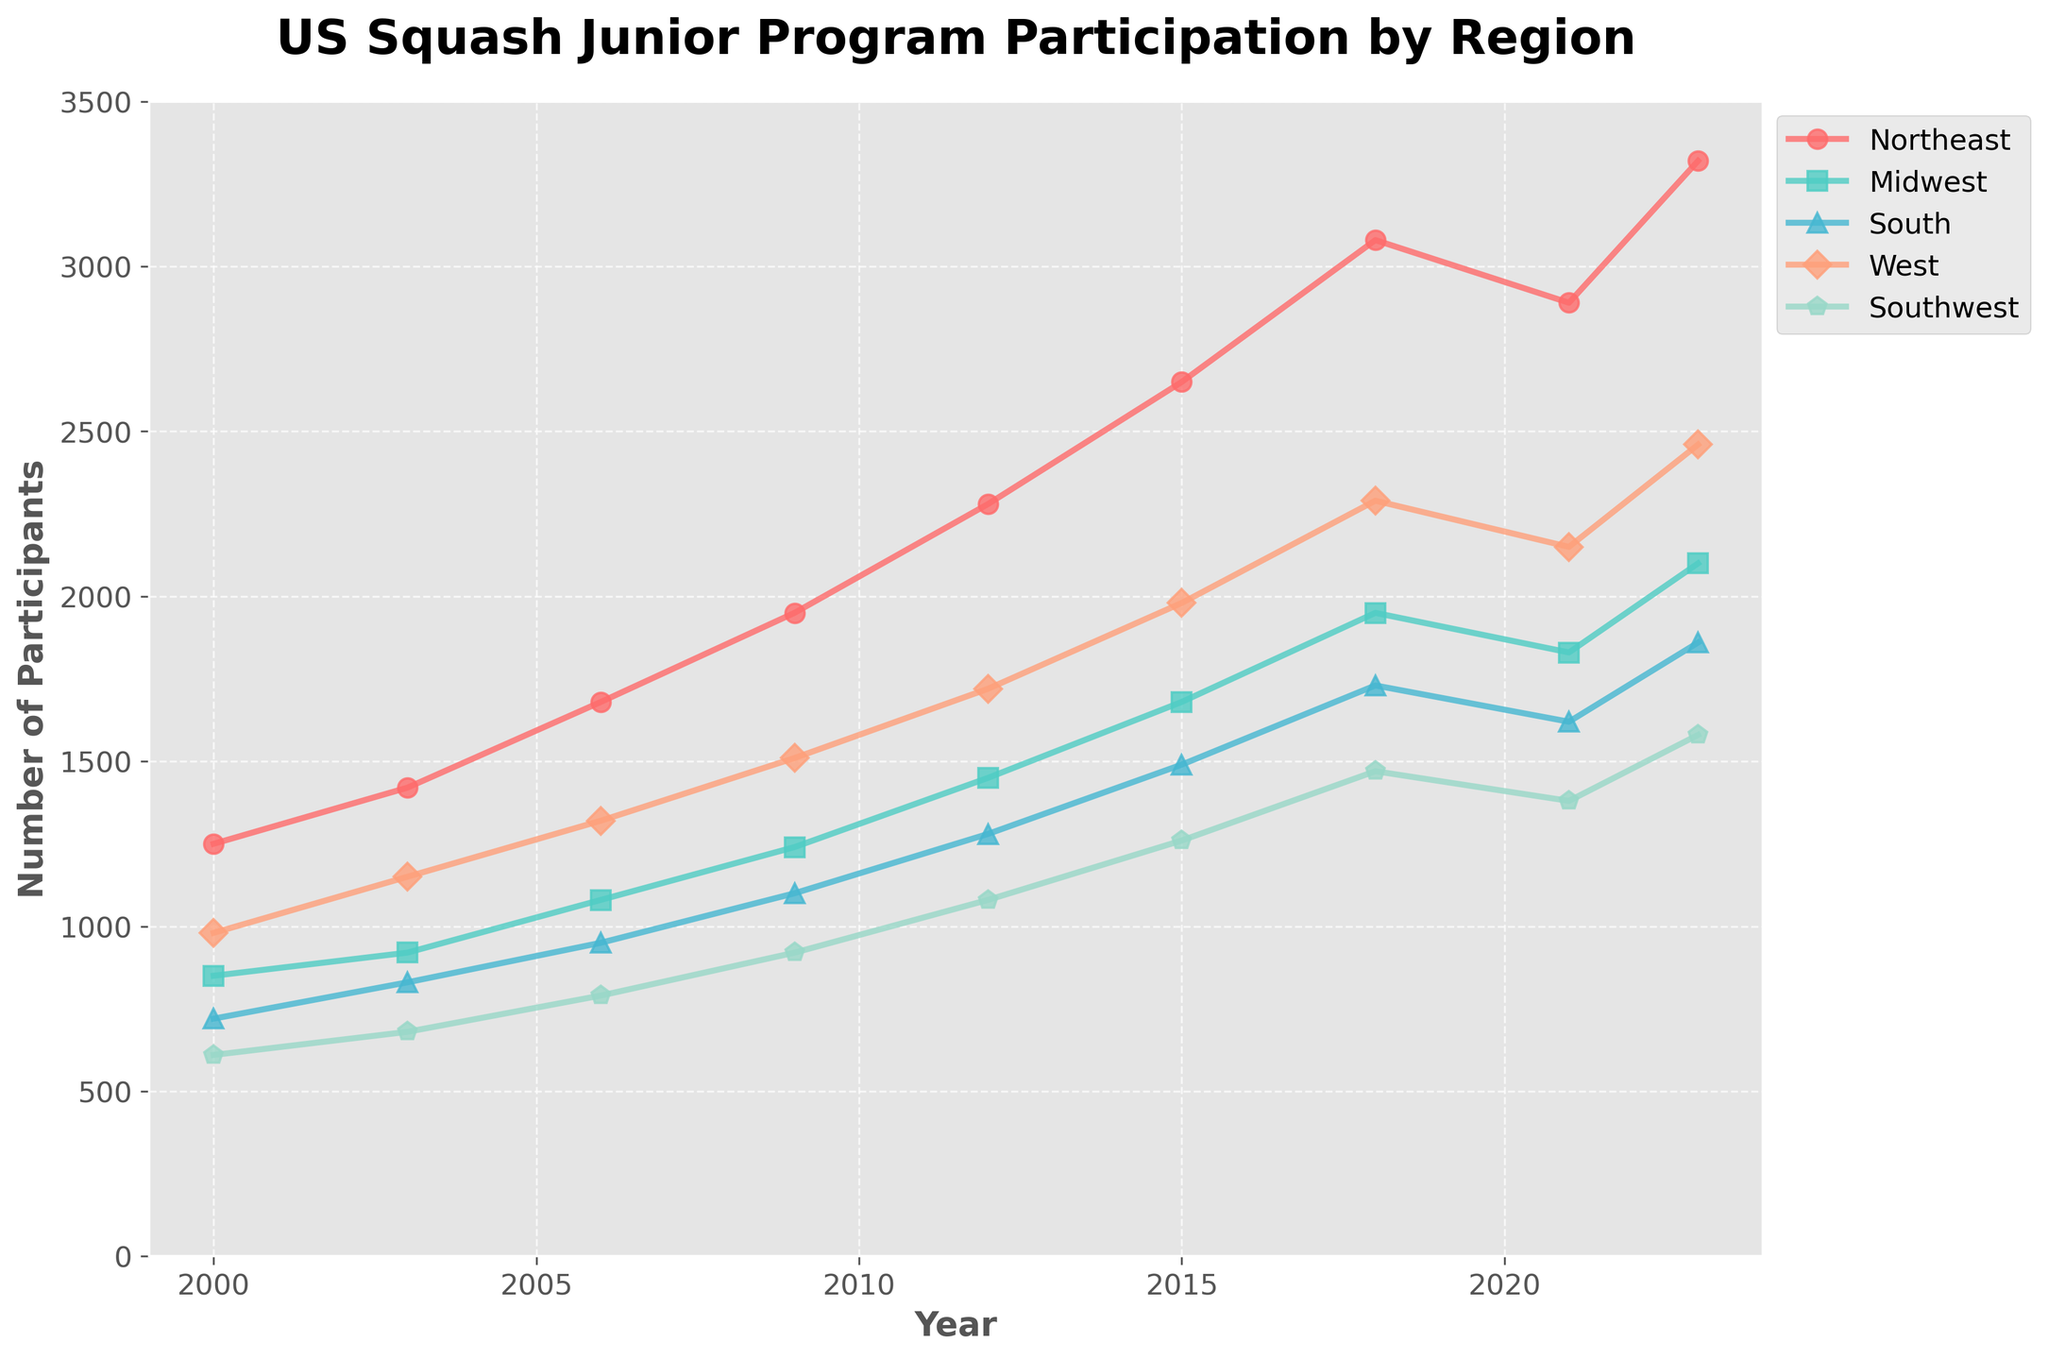Which region showed the highest participation in 2023? The highest participation can be identified by comparing the final data points for each region in 2023. The Northeast has the highest value at 3320 participants.
Answer: Northeast By how much did the participation in the South region increase from 2000 to 2023? To find the increase, subtract the 2000 value from the 2023 value for the South region. It is 1860 - 720 = 1140.
Answer: 1140 Which region experienced the largest growth in participation from 2000 to 2023? Calculate the change in participation for each region from 2000 to 2023, then compare the values. The Northeast grew by 3320 - 1250 = 2070, Midwest by 2100 - 850 = 1250, South by 1860 - 720 = 1140, West by 2460 - 980 = 1480, and Southwest by 1580 - 610 = 970. The largest growth is in the Northeast.
Answer: Northeast Did any region experience a decline in participation between any two consecutive periods? Check the differences in participation between consecutive years for each region. The West region showed a decline from 2018 (2290) to 2021 (2150) and the Northeast from 2018 (3080) to 2021 (2890).
Answer: Yes Which region had the least participation in the year 2000? Look at the 2000 data points for each region and identify the smallest value. The Southwest had the least participation with 610 participants.
Answer: Southwest What was the average participation across all regions in 2023? Sum the 2023 participation values and divide by the number of regions. (3320 + 2100 + 1860 + 2460 + 1580) / 5 = 2264.
Answer: 2264 Between which two consecutive periods did the Northeast region see the largest increase in participation? Calculate the differences in participation between consecutive periods for the Northeast region. The largest increase is between 2018 (3080) and 2023 (3320) which is 3320 - 3080 = 240.
Answer: 2018-2023 Which region had the smallest growth in participation from 2000 to 2023? Calculate the difference in participation for each region from 2000 to 2023 and identify the smallest value. The Southwest grew by 1580 - 610 = 970, the least among all regions.
Answer: Southwest By how much did the participation in the Midwest region change between 2006 and 2009? Subtract the 2006 value from the 2009 value for the Midwest. It is 1240 - 1080 = 160.
Answer: 160 What is the trend of participation in the West region from 2018 to 2021? Look at the values for the West region in 2018 and 2021. There is a decline from 2290 in 2018 to 2150 in 2021, indicating a decreasing trend.
Answer: Decreasing 